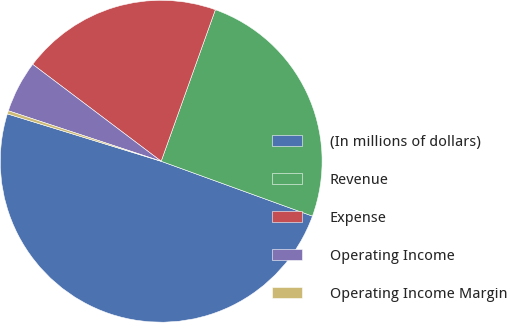<chart> <loc_0><loc_0><loc_500><loc_500><pie_chart><fcel>(In millions of dollars)<fcel>Revenue<fcel>Expense<fcel>Operating Income<fcel>Operating Income Margin<nl><fcel>49.22%<fcel>25.07%<fcel>20.18%<fcel>5.21%<fcel>0.32%<nl></chart> 